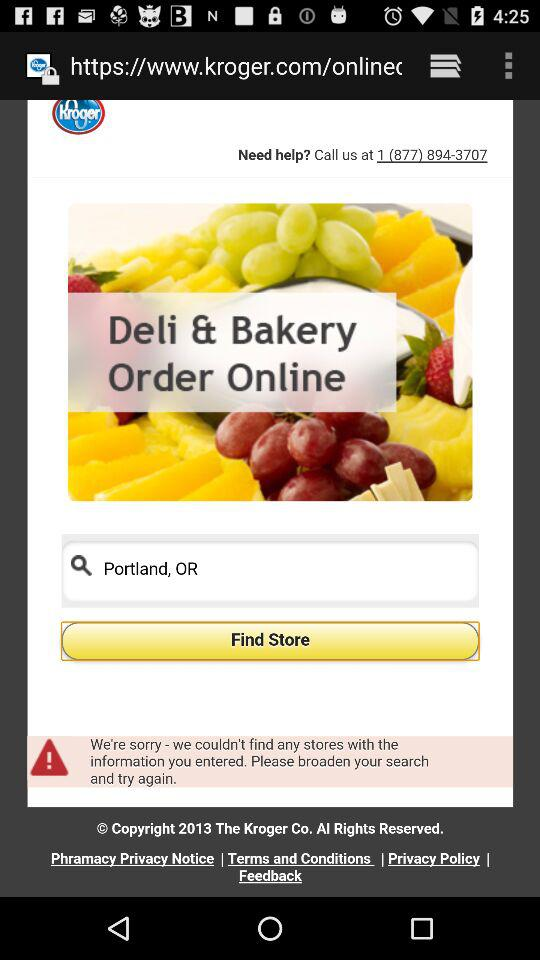What is the helpline number? The helpline number is 1 (877) 894-3707. 